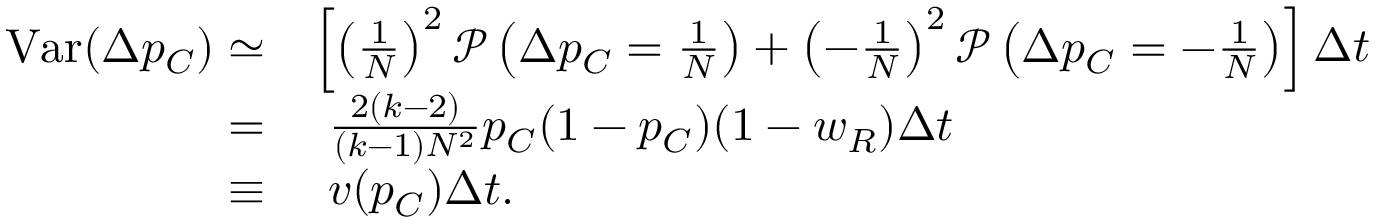Convert formula to latex. <formula><loc_0><loc_0><loc_500><loc_500>\begin{array} { r l } { V a r ( \Delta p _ { C } ) \simeq } & { \left [ \left ( \frac { 1 } { N } \right ) ^ { 2 } \mathcal { P } \left ( \Delta p _ { C } = \frac { 1 } { N } \right ) + \left ( - \frac { 1 } { N } \right ) ^ { 2 } \mathcal { P } \left ( \Delta p _ { C } = - \frac { 1 } { N } \right ) \right ] \Delta t } \\ { = } & { \frac { 2 ( k - 2 ) } { ( k - 1 ) N ^ { 2 } } p _ { C } ( 1 - p _ { C } ) ( 1 - w _ { R } ) \Delta t } \\ { \equiv } & { v ( p _ { C } ) \Delta t . } \end{array}</formula> 